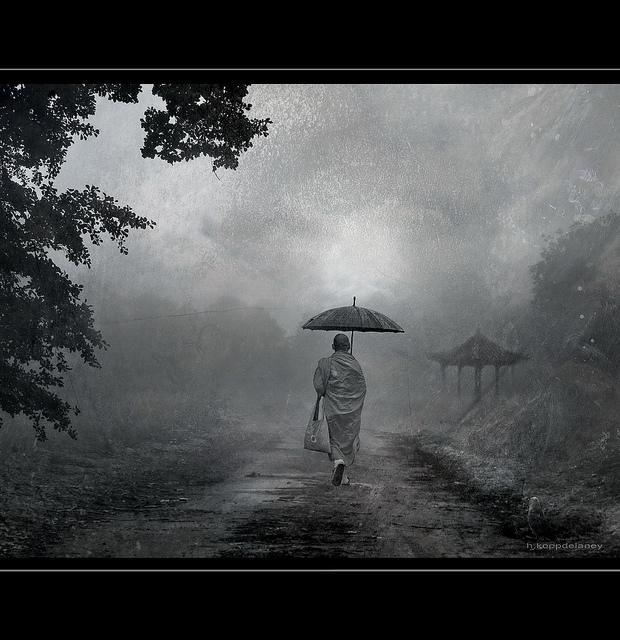What sort of architecture is shown in the background?
Keep it brief. Gazebo. Is this person avoiding puddles by walking on the middle strip?
Give a very brief answer. Yes. Is this person trying to escape from the rain?
Give a very brief answer. No. 